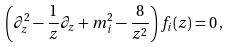<formula> <loc_0><loc_0><loc_500><loc_500>\left ( \partial _ { z } ^ { 2 } - \frac { 1 } { z } \partial _ { z } + m _ { i } ^ { 2 } - \frac { 8 } { z ^ { 2 } } \right ) f _ { i } ( z ) = 0 \, ,</formula> 